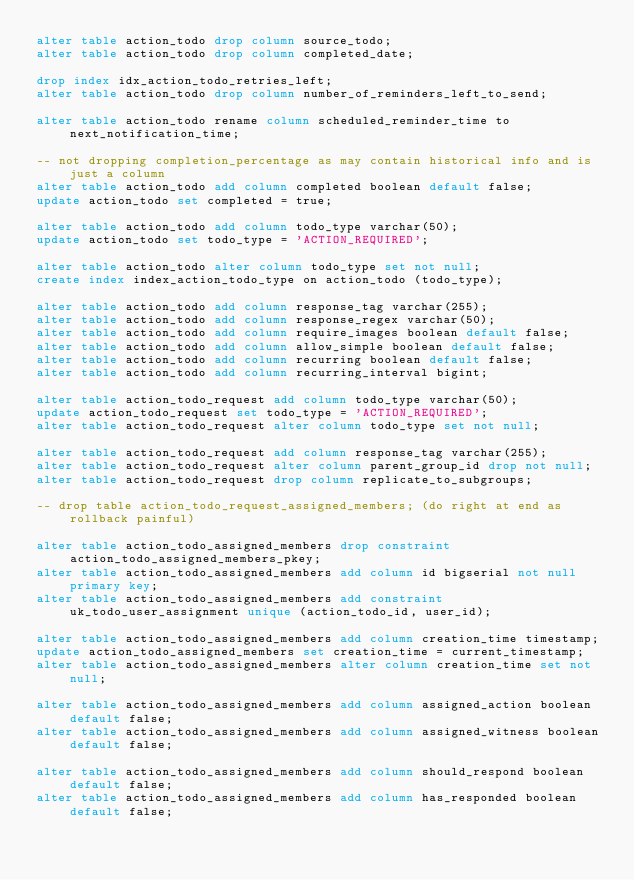<code> <loc_0><loc_0><loc_500><loc_500><_SQL_>alter table action_todo drop column source_todo;
alter table action_todo drop column completed_date;

drop index idx_action_todo_retries_left;
alter table action_todo drop column number_of_reminders_left_to_send;

alter table action_todo rename column scheduled_reminder_time to next_notification_time;

-- not dropping completion_percentage as may contain historical info and is just a column
alter table action_todo add column completed boolean default false;
update action_todo set completed = true;

alter table action_todo add column todo_type varchar(50);
update action_todo set todo_type = 'ACTION_REQUIRED';

alter table action_todo alter column todo_type set not null;
create index index_action_todo_type on action_todo (todo_type);

alter table action_todo add column response_tag varchar(255);
alter table action_todo add column response_regex varchar(50);
alter table action_todo add column require_images boolean default false;
alter table action_todo add column allow_simple boolean default false;
alter table action_todo add column recurring boolean default false;
alter table action_todo add column recurring_interval bigint;

alter table action_todo_request add column todo_type varchar(50);
update action_todo_request set todo_type = 'ACTION_REQUIRED';
alter table action_todo_request alter column todo_type set not null;

alter table action_todo_request add column response_tag varchar(255);
alter table action_todo_request alter column parent_group_id drop not null;
alter table action_todo_request drop column replicate_to_subgroups;

-- drop table action_todo_request_assigned_members; (do right at end as rollback painful)

alter table action_todo_assigned_members drop constraint action_todo_assigned_members_pkey;
alter table action_todo_assigned_members add column id bigserial not null primary key;
alter table action_todo_assigned_members add constraint uk_todo_user_assignment unique (action_todo_id, user_id);

alter table action_todo_assigned_members add column creation_time timestamp;
update action_todo_assigned_members set creation_time = current_timestamp;
alter table action_todo_assigned_members alter column creation_time set not null;

alter table action_todo_assigned_members add column assigned_action boolean default false;
alter table action_todo_assigned_members add column assigned_witness boolean default false;

alter table action_todo_assigned_members add column should_respond boolean default false;
alter table action_todo_assigned_members add column has_responded boolean default false;</code> 